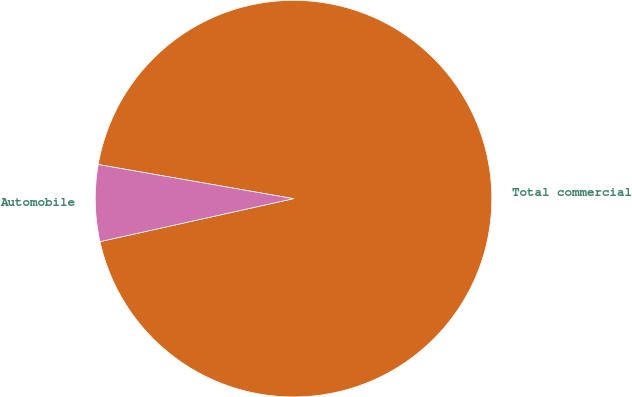Convert chart. <chart><loc_0><loc_0><loc_500><loc_500><pie_chart><fcel>Total commercial<fcel>Automobile<nl><fcel>93.77%<fcel>6.23%<nl></chart> 